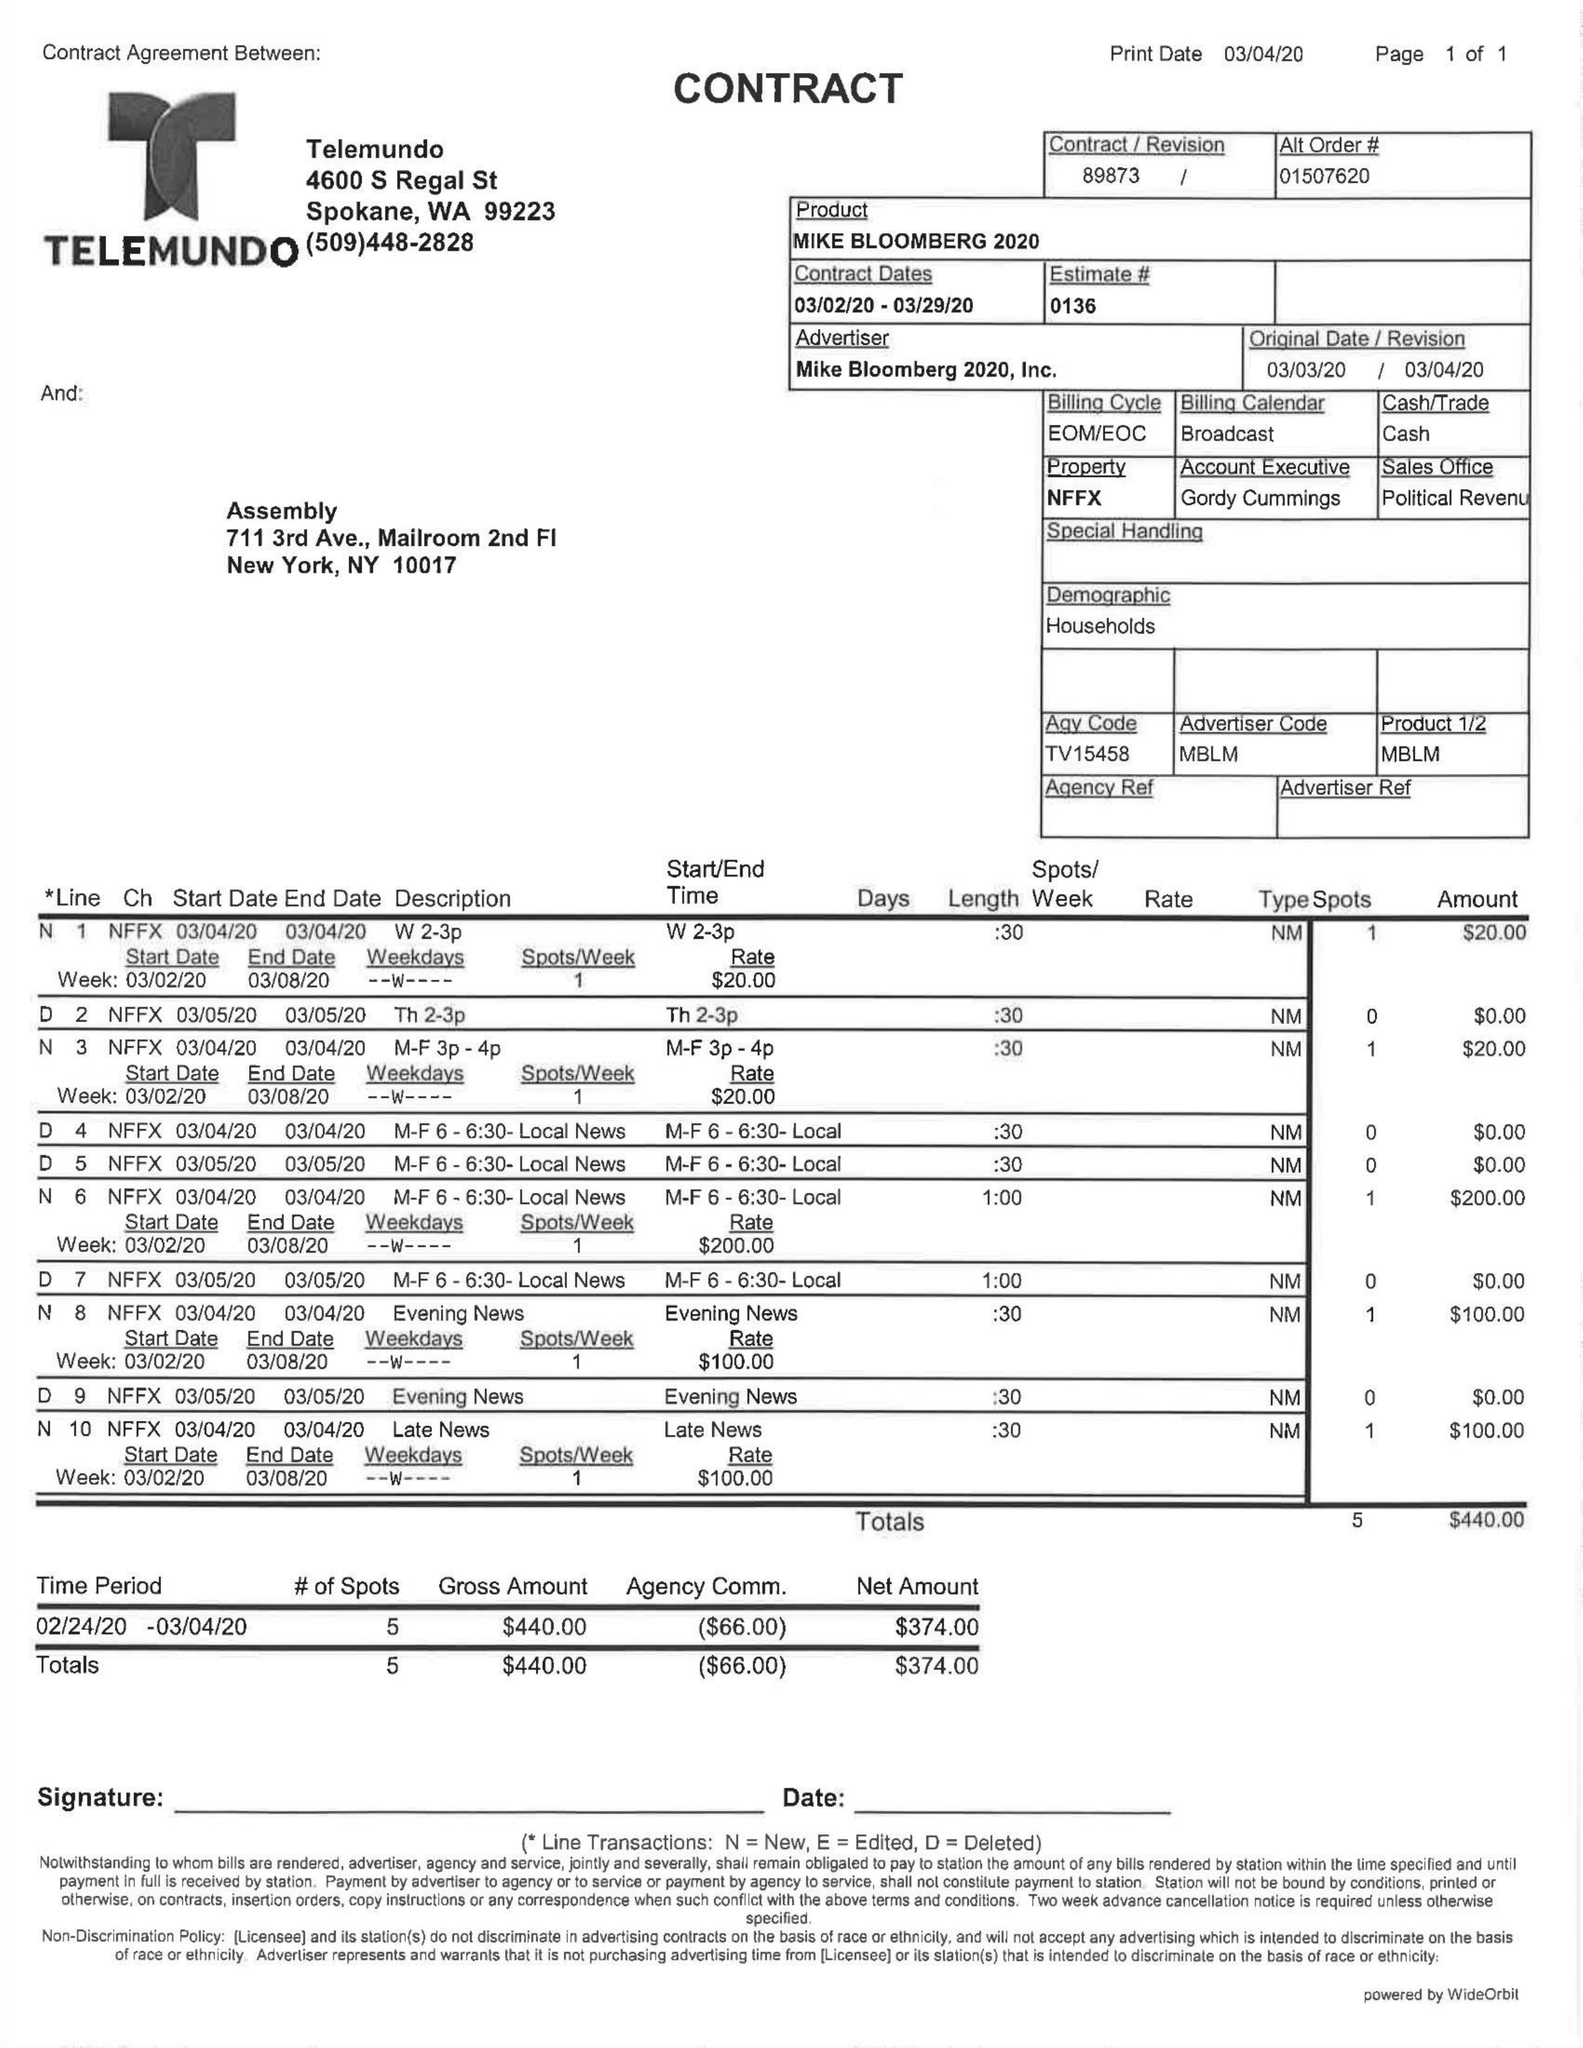What is the value for the gross_amount?
Answer the question using a single word or phrase. 440.00 